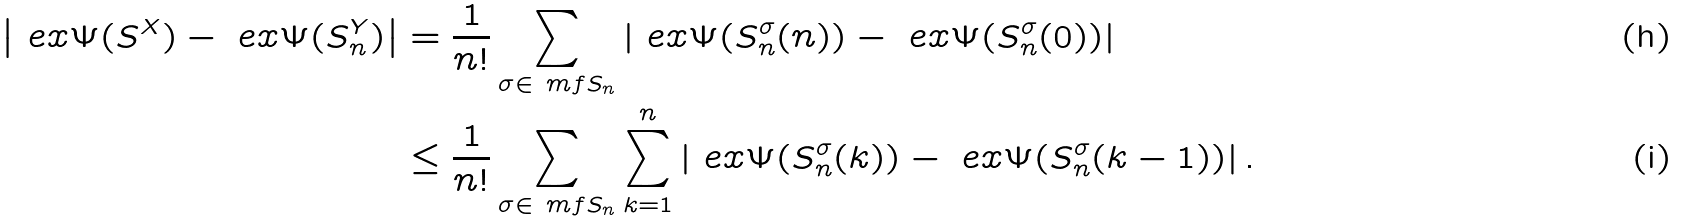<formula> <loc_0><loc_0><loc_500><loc_500>\left | \ e x { \Psi ( S ^ { X } ) } - \ e x { \Psi ( S _ { n } ^ { Y } ) } \right | & = \frac { 1 } { n ! } \sum _ { \sigma \in \ m f { S } _ { n } } \left | \ e x { \Psi ( S _ { n } ^ { \sigma } ( n ) ) } - \ e x { \Psi ( S _ { n } ^ { \sigma } ( 0 ) ) } \right | \\ & \leq \frac { 1 } { n ! } \sum _ { \sigma \in \ m f { S } _ { n } } \sum _ { k = 1 } ^ { n } \left | \ e x { \Psi ( S _ { n } ^ { \sigma } ( k ) ) } - \ e x { \Psi ( S _ { n } ^ { \sigma } ( k - 1 ) ) } \right | .</formula> 